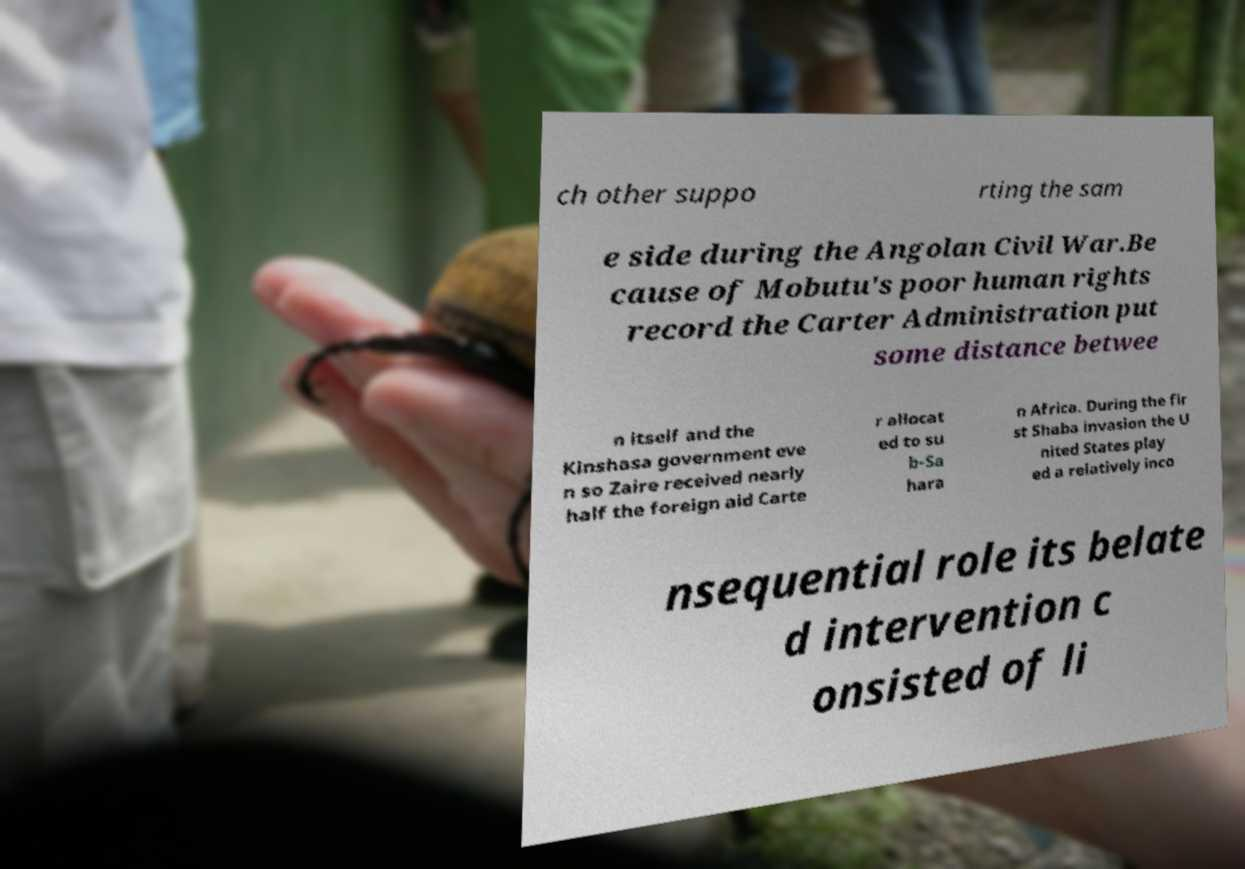Could you extract and type out the text from this image? ch other suppo rting the sam e side during the Angolan Civil War.Be cause of Mobutu's poor human rights record the Carter Administration put some distance betwee n itself and the Kinshasa government eve n so Zaire received nearly half the foreign aid Carte r allocat ed to su b-Sa hara n Africa. During the fir st Shaba invasion the U nited States play ed a relatively inco nsequential role its belate d intervention c onsisted of li 